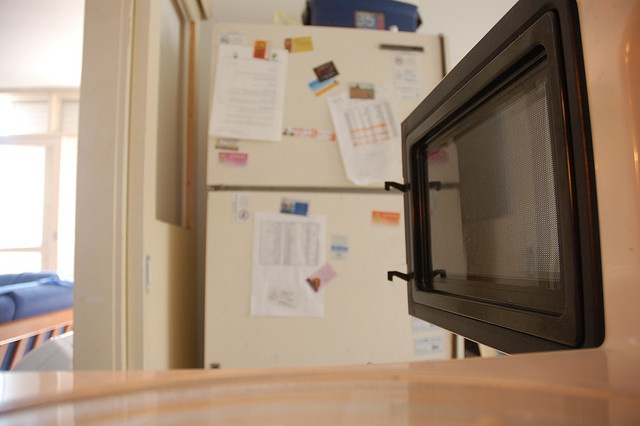Describe the objects in this image and their specific colors. I can see refrigerator in darkgray, tan, and lightgray tones, microwave in darkgray, black, and gray tones, and couch in darkgray, tan, and gray tones in this image. 